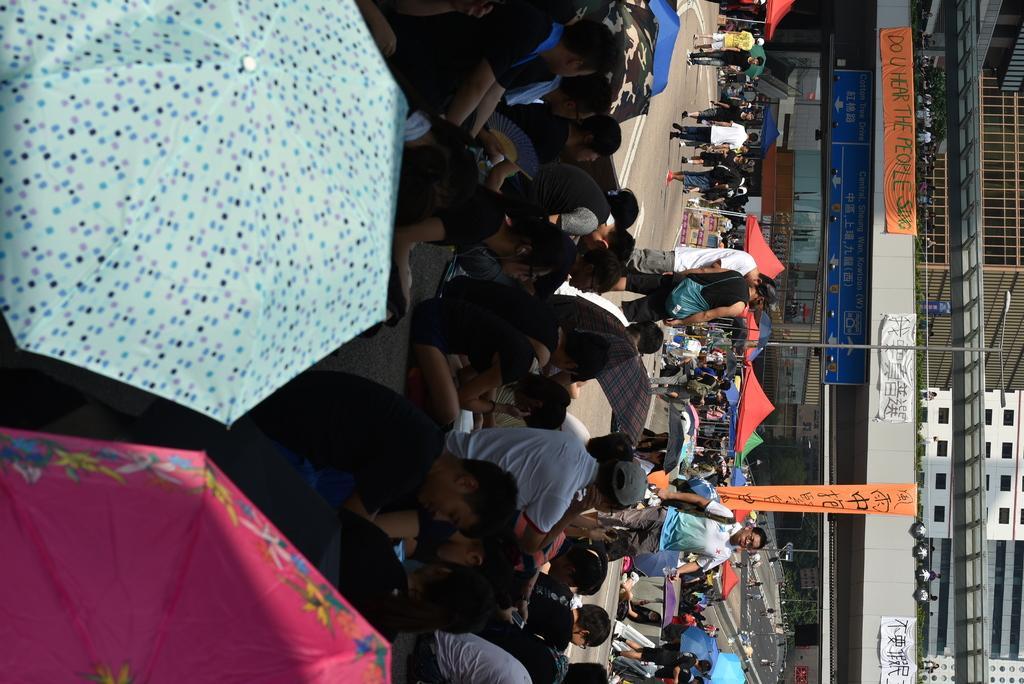Could you give a brief overview of what you see in this image? In this image there are group of people sitting and holding the umbrellas, group of people standing , banners, buildings, name board, plants, stalls. 